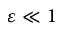Convert formula to latex. <formula><loc_0><loc_0><loc_500><loc_500>\varepsilon \ll 1</formula> 